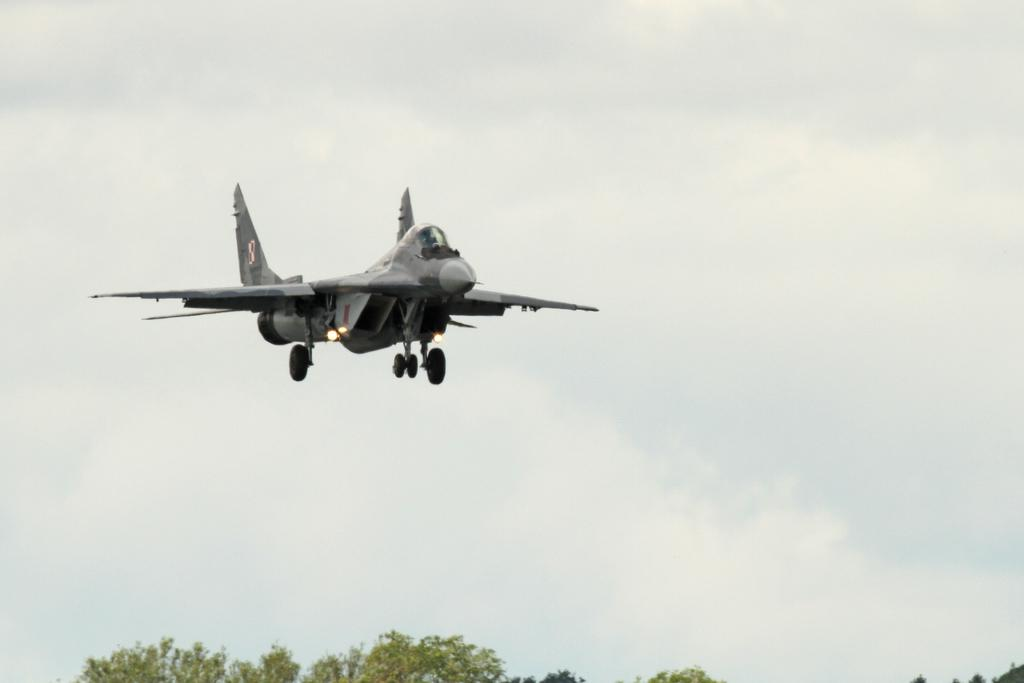What is the main subject of the image? There is an aircraft in the image. What can be seen in the background of the image? There are trees in the background of the image. What is the color of the trees? The trees are green in color. What else is visible in the image? The sky is visible in the image. What type of quilt is being used to cover the nation in the image? There is no quilt or nation present in the image; it features an aircraft and trees in the background. What type of clouds can be seen in the sky in the image? The sky is white in color, and there is no mention of clouds in the image. 